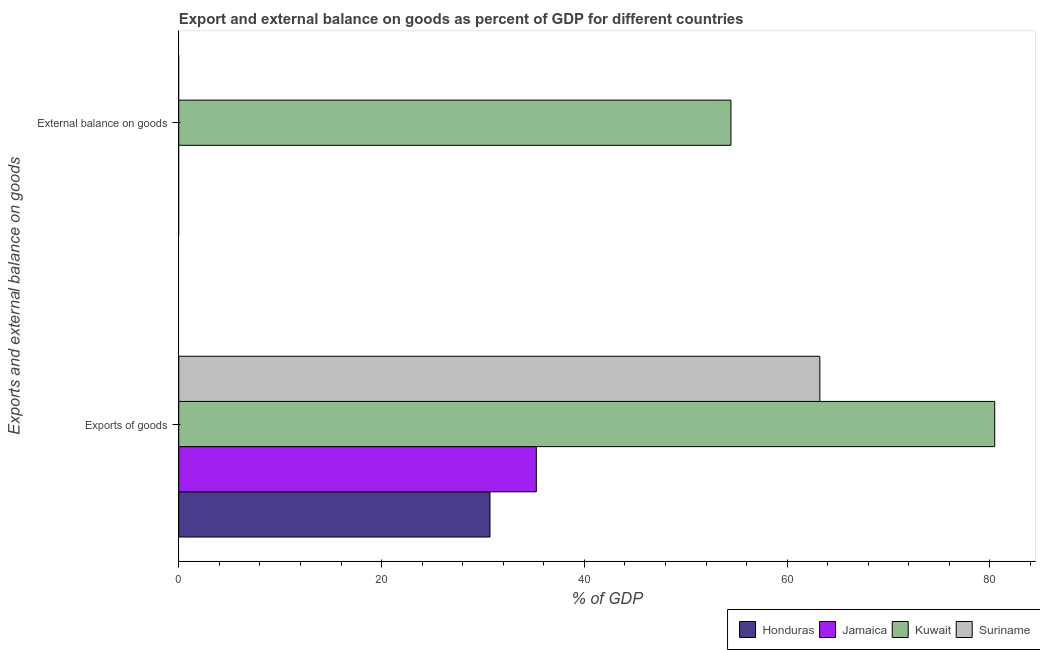How many different coloured bars are there?
Your response must be concise. 4. How many bars are there on the 2nd tick from the top?
Offer a very short reply. 4. How many bars are there on the 2nd tick from the bottom?
Offer a very short reply. 1. What is the label of the 2nd group of bars from the top?
Your response must be concise. Exports of goods. What is the external balance on goods as percentage of gdp in Suriname?
Your response must be concise. 0. Across all countries, what is the maximum export of goods as percentage of gdp?
Your answer should be very brief. 80.47. In which country was the export of goods as percentage of gdp maximum?
Your answer should be compact. Kuwait. What is the total external balance on goods as percentage of gdp in the graph?
Give a very brief answer. 54.46. What is the difference between the export of goods as percentage of gdp in Suriname and that in Jamaica?
Your answer should be very brief. 27.96. What is the difference between the export of goods as percentage of gdp in Suriname and the external balance on goods as percentage of gdp in Honduras?
Keep it short and to the point. 63.23. What is the average export of goods as percentage of gdp per country?
Provide a short and direct response. 52.41. What is the difference between the external balance on goods as percentage of gdp and export of goods as percentage of gdp in Kuwait?
Ensure brevity in your answer.  -26.01. In how many countries, is the external balance on goods as percentage of gdp greater than 8 %?
Your answer should be compact. 1. What is the ratio of the export of goods as percentage of gdp in Honduras to that in Kuwait?
Give a very brief answer. 0.38. In how many countries, is the export of goods as percentage of gdp greater than the average export of goods as percentage of gdp taken over all countries?
Your answer should be compact. 2. How many bars are there?
Your answer should be compact. 5. How many countries are there in the graph?
Ensure brevity in your answer.  4. What is the difference between two consecutive major ticks on the X-axis?
Keep it short and to the point. 20. Are the values on the major ticks of X-axis written in scientific E-notation?
Offer a terse response. No. Does the graph contain any zero values?
Your answer should be compact. Yes. Does the graph contain grids?
Make the answer very short. No. What is the title of the graph?
Your answer should be compact. Export and external balance on goods as percent of GDP for different countries. What is the label or title of the X-axis?
Provide a succinct answer. % of GDP. What is the label or title of the Y-axis?
Keep it short and to the point. Exports and external balance on goods. What is the % of GDP of Honduras in Exports of goods?
Make the answer very short. 30.69. What is the % of GDP of Jamaica in Exports of goods?
Give a very brief answer. 35.26. What is the % of GDP of Kuwait in Exports of goods?
Offer a very short reply. 80.47. What is the % of GDP of Suriname in Exports of goods?
Give a very brief answer. 63.23. What is the % of GDP of Honduras in External balance on goods?
Offer a terse response. 0. What is the % of GDP in Jamaica in External balance on goods?
Keep it short and to the point. 0. What is the % of GDP of Kuwait in External balance on goods?
Keep it short and to the point. 54.46. What is the % of GDP in Suriname in External balance on goods?
Provide a short and direct response. 0. Across all Exports and external balance on goods, what is the maximum % of GDP of Honduras?
Offer a terse response. 30.69. Across all Exports and external balance on goods, what is the maximum % of GDP in Jamaica?
Provide a short and direct response. 35.26. Across all Exports and external balance on goods, what is the maximum % of GDP of Kuwait?
Offer a very short reply. 80.47. Across all Exports and external balance on goods, what is the maximum % of GDP of Suriname?
Make the answer very short. 63.23. Across all Exports and external balance on goods, what is the minimum % of GDP in Kuwait?
Your answer should be compact. 54.46. What is the total % of GDP of Honduras in the graph?
Your response must be concise. 30.69. What is the total % of GDP of Jamaica in the graph?
Offer a very short reply. 35.26. What is the total % of GDP of Kuwait in the graph?
Offer a terse response. 134.93. What is the total % of GDP in Suriname in the graph?
Provide a succinct answer. 63.23. What is the difference between the % of GDP in Kuwait in Exports of goods and that in External balance on goods?
Keep it short and to the point. 26.01. What is the difference between the % of GDP in Honduras in Exports of goods and the % of GDP in Kuwait in External balance on goods?
Provide a short and direct response. -23.77. What is the difference between the % of GDP of Jamaica in Exports of goods and the % of GDP of Kuwait in External balance on goods?
Provide a succinct answer. -19.2. What is the average % of GDP of Honduras per Exports and external balance on goods?
Your response must be concise. 15.35. What is the average % of GDP of Jamaica per Exports and external balance on goods?
Keep it short and to the point. 17.63. What is the average % of GDP in Kuwait per Exports and external balance on goods?
Your answer should be very brief. 67.46. What is the average % of GDP of Suriname per Exports and external balance on goods?
Keep it short and to the point. 31.61. What is the difference between the % of GDP in Honduras and % of GDP in Jamaica in Exports of goods?
Make the answer very short. -4.57. What is the difference between the % of GDP of Honduras and % of GDP of Kuwait in Exports of goods?
Your answer should be compact. -49.78. What is the difference between the % of GDP of Honduras and % of GDP of Suriname in Exports of goods?
Your response must be concise. -32.53. What is the difference between the % of GDP in Jamaica and % of GDP in Kuwait in Exports of goods?
Provide a succinct answer. -45.21. What is the difference between the % of GDP of Jamaica and % of GDP of Suriname in Exports of goods?
Keep it short and to the point. -27.96. What is the difference between the % of GDP of Kuwait and % of GDP of Suriname in Exports of goods?
Your answer should be very brief. 17.24. What is the ratio of the % of GDP in Kuwait in Exports of goods to that in External balance on goods?
Ensure brevity in your answer.  1.48. What is the difference between the highest and the second highest % of GDP in Kuwait?
Your answer should be compact. 26.01. What is the difference between the highest and the lowest % of GDP in Honduras?
Keep it short and to the point. 30.69. What is the difference between the highest and the lowest % of GDP in Jamaica?
Provide a short and direct response. 35.26. What is the difference between the highest and the lowest % of GDP of Kuwait?
Provide a succinct answer. 26.01. What is the difference between the highest and the lowest % of GDP in Suriname?
Your answer should be compact. 63.23. 